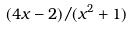<formula> <loc_0><loc_0><loc_500><loc_500>( 4 x - 2 ) / ( x ^ { 2 } + 1 )</formula> 